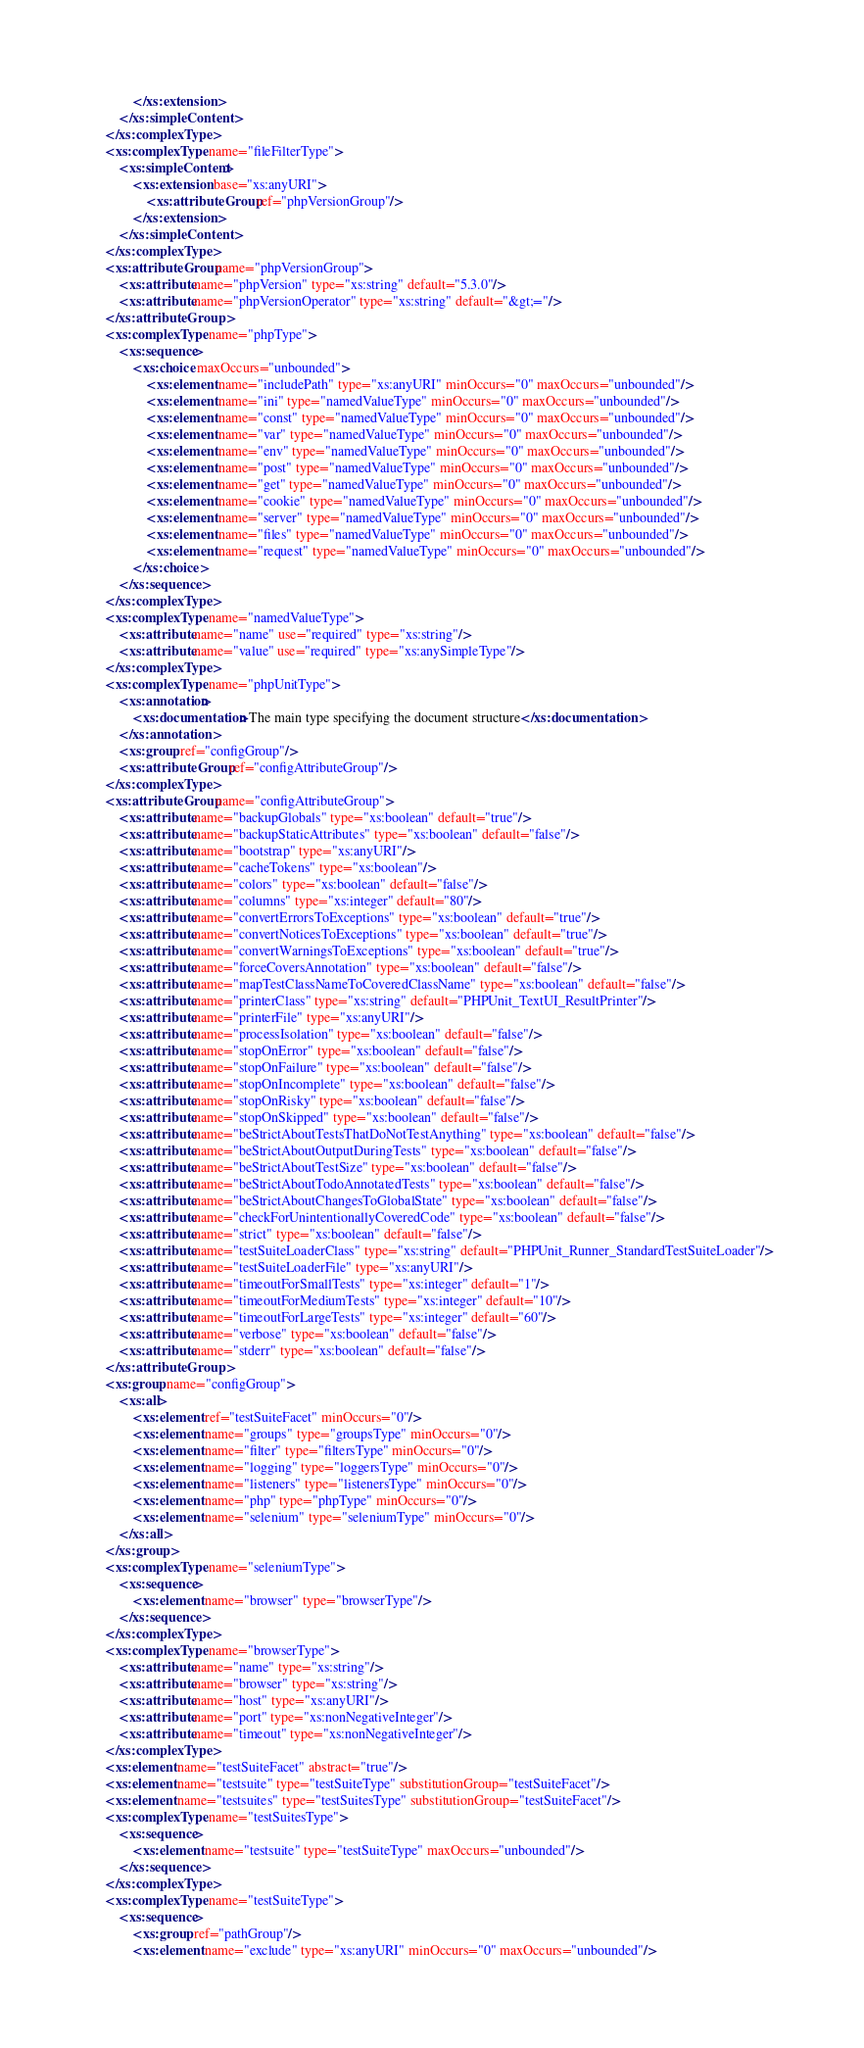<code> <loc_0><loc_0><loc_500><loc_500><_XML_>            </xs:extension>
        </xs:simpleContent>
    </xs:complexType>
    <xs:complexType name="fileFilterType">
        <xs:simpleContent>
            <xs:extension base="xs:anyURI">
                <xs:attributeGroup ref="phpVersionGroup"/>
            </xs:extension>
        </xs:simpleContent>
    </xs:complexType>
    <xs:attributeGroup name="phpVersionGroup">
        <xs:attribute name="phpVersion" type="xs:string" default="5.3.0"/>
        <xs:attribute name="phpVersionOperator" type="xs:string" default="&gt;="/>
    </xs:attributeGroup>
    <xs:complexType name="phpType">
        <xs:sequence>
            <xs:choice maxOccurs="unbounded">
                <xs:element name="includePath" type="xs:anyURI" minOccurs="0" maxOccurs="unbounded"/>
                <xs:element name="ini" type="namedValueType" minOccurs="0" maxOccurs="unbounded"/>
                <xs:element name="const" type="namedValueType" minOccurs="0" maxOccurs="unbounded"/>
                <xs:element name="var" type="namedValueType" minOccurs="0" maxOccurs="unbounded"/>
                <xs:element name="env" type="namedValueType" minOccurs="0" maxOccurs="unbounded"/>
                <xs:element name="post" type="namedValueType" minOccurs="0" maxOccurs="unbounded"/>
                <xs:element name="get" type="namedValueType" minOccurs="0" maxOccurs="unbounded"/>
                <xs:element name="cookie" type="namedValueType" minOccurs="0" maxOccurs="unbounded"/>
                <xs:element name="server" type="namedValueType" minOccurs="0" maxOccurs="unbounded"/>
                <xs:element name="files" type="namedValueType" minOccurs="0" maxOccurs="unbounded"/>
                <xs:element name="request" type="namedValueType" minOccurs="0" maxOccurs="unbounded"/>
            </xs:choice>
        </xs:sequence>
    </xs:complexType>
    <xs:complexType name="namedValueType">
        <xs:attribute name="name" use="required" type="xs:string"/>
        <xs:attribute name="value" use="required" type="xs:anySimpleType"/>
    </xs:complexType>
    <xs:complexType name="phpUnitType">
        <xs:annotation>
            <xs:documentation>The main type specifying the document structure</xs:documentation>
        </xs:annotation>
        <xs:group ref="configGroup"/>
        <xs:attributeGroup ref="configAttributeGroup"/>
    </xs:complexType>
    <xs:attributeGroup name="configAttributeGroup">
        <xs:attribute name="backupGlobals" type="xs:boolean" default="true"/>
        <xs:attribute name="backupStaticAttributes" type="xs:boolean" default="false"/>
        <xs:attribute name="bootstrap" type="xs:anyURI"/>
        <xs:attribute name="cacheTokens" type="xs:boolean"/>
        <xs:attribute name="colors" type="xs:boolean" default="false"/>
        <xs:attribute name="columns" type="xs:integer" default="80"/>
        <xs:attribute name="convertErrorsToExceptions" type="xs:boolean" default="true"/>
        <xs:attribute name="convertNoticesToExceptions" type="xs:boolean" default="true"/>
        <xs:attribute name="convertWarningsToExceptions" type="xs:boolean" default="true"/>
        <xs:attribute name="forceCoversAnnotation" type="xs:boolean" default="false"/>
        <xs:attribute name="mapTestClassNameToCoveredClassName" type="xs:boolean" default="false"/>
        <xs:attribute name="printerClass" type="xs:string" default="PHPUnit_TextUI_ResultPrinter"/>
        <xs:attribute name="printerFile" type="xs:anyURI"/>
        <xs:attribute name="processIsolation" type="xs:boolean" default="false"/>
        <xs:attribute name="stopOnError" type="xs:boolean" default="false"/>
        <xs:attribute name="stopOnFailure" type="xs:boolean" default="false"/>
        <xs:attribute name="stopOnIncomplete" type="xs:boolean" default="false"/>
        <xs:attribute name="stopOnRisky" type="xs:boolean" default="false"/>
        <xs:attribute name="stopOnSkipped" type="xs:boolean" default="false"/>
        <xs:attribute name="beStrictAboutTestsThatDoNotTestAnything" type="xs:boolean" default="false"/>
        <xs:attribute name="beStrictAboutOutputDuringTests" type="xs:boolean" default="false"/>
        <xs:attribute name="beStrictAboutTestSize" type="xs:boolean" default="false"/>
        <xs:attribute name="beStrictAboutTodoAnnotatedTests" type="xs:boolean" default="false"/>
        <xs:attribute name="beStrictAboutChangesToGlobalState" type="xs:boolean" default="false"/>
        <xs:attribute name="checkForUnintentionallyCoveredCode" type="xs:boolean" default="false"/>
        <xs:attribute name="strict" type="xs:boolean" default="false"/>
        <xs:attribute name="testSuiteLoaderClass" type="xs:string" default="PHPUnit_Runner_StandardTestSuiteLoader"/>
        <xs:attribute name="testSuiteLoaderFile" type="xs:anyURI"/>
        <xs:attribute name="timeoutForSmallTests" type="xs:integer" default="1"/>
        <xs:attribute name="timeoutForMediumTests" type="xs:integer" default="10"/>
        <xs:attribute name="timeoutForLargeTests" type="xs:integer" default="60"/>
        <xs:attribute name="verbose" type="xs:boolean" default="false"/>
        <xs:attribute name="stderr" type="xs:boolean" default="false"/>
    </xs:attributeGroup>
    <xs:group name="configGroup">
        <xs:all>
            <xs:element ref="testSuiteFacet" minOccurs="0"/>
            <xs:element name="groups" type="groupsType" minOccurs="0"/>
            <xs:element name="filter" type="filtersType" minOccurs="0"/>
            <xs:element name="logging" type="loggersType" minOccurs="0"/>
            <xs:element name="listeners" type="listenersType" minOccurs="0"/>
            <xs:element name="php" type="phpType" minOccurs="0"/>
            <xs:element name="selenium" type="seleniumType" minOccurs="0"/>
        </xs:all>
    </xs:group>
    <xs:complexType name="seleniumType">
        <xs:sequence>
            <xs:element name="browser" type="browserType"/>
        </xs:sequence>
    </xs:complexType>
    <xs:complexType name="browserType">
        <xs:attribute name="name" type="xs:string"/>
        <xs:attribute name="browser" type="xs:string"/>
        <xs:attribute name="host" type="xs:anyURI"/>
        <xs:attribute name="port" type="xs:nonNegativeInteger"/>
        <xs:attribute name="timeout" type="xs:nonNegativeInteger"/>
    </xs:complexType>
    <xs:element name="testSuiteFacet" abstract="true"/>
    <xs:element name="testsuite" type="testSuiteType" substitutionGroup="testSuiteFacet"/>
    <xs:element name="testsuites" type="testSuitesType" substitutionGroup="testSuiteFacet"/>
    <xs:complexType name="testSuitesType">
        <xs:sequence>
            <xs:element name="testsuite" type="testSuiteType" maxOccurs="unbounded"/>
        </xs:sequence>
    </xs:complexType>
    <xs:complexType name="testSuiteType">
        <xs:sequence>
            <xs:group ref="pathGroup"/>
            <xs:element name="exclude" type="xs:anyURI" minOccurs="0" maxOccurs="unbounded"/></code> 